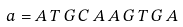<formula> <loc_0><loc_0><loc_500><loc_500>a = A \, T \, G \, C \, A \, A \, G \, T \, G \, A</formula> 